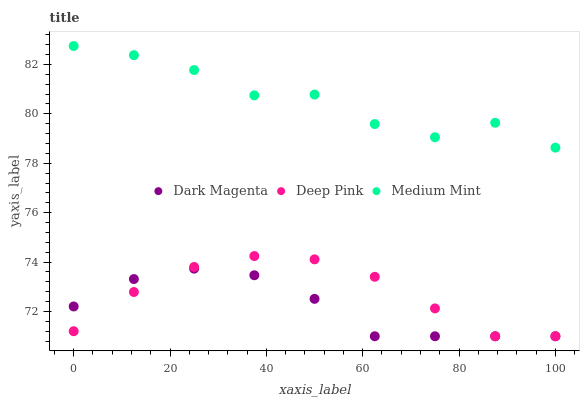Does Dark Magenta have the minimum area under the curve?
Answer yes or no. Yes. Does Medium Mint have the maximum area under the curve?
Answer yes or no. Yes. Does Deep Pink have the minimum area under the curve?
Answer yes or no. No. Does Deep Pink have the maximum area under the curve?
Answer yes or no. No. Is Dark Magenta the smoothest?
Answer yes or no. Yes. Is Medium Mint the roughest?
Answer yes or no. Yes. Is Deep Pink the smoothest?
Answer yes or no. No. Is Deep Pink the roughest?
Answer yes or no. No. Does Deep Pink have the lowest value?
Answer yes or no. Yes. Does Medium Mint have the highest value?
Answer yes or no. Yes. Does Deep Pink have the highest value?
Answer yes or no. No. Is Dark Magenta less than Medium Mint?
Answer yes or no. Yes. Is Medium Mint greater than Deep Pink?
Answer yes or no. Yes. Does Dark Magenta intersect Deep Pink?
Answer yes or no. Yes. Is Dark Magenta less than Deep Pink?
Answer yes or no. No. Is Dark Magenta greater than Deep Pink?
Answer yes or no. No. Does Dark Magenta intersect Medium Mint?
Answer yes or no. No. 